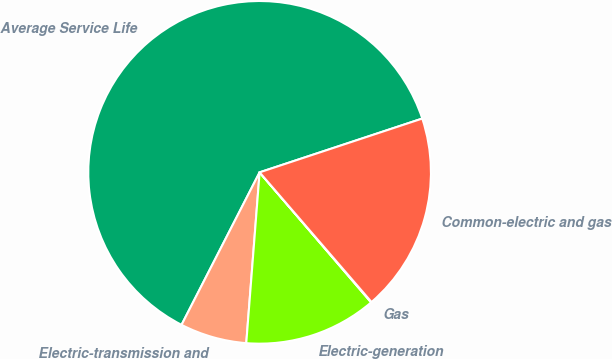Convert chart to OTSL. <chart><loc_0><loc_0><loc_500><loc_500><pie_chart><fcel>Average Service Life<fcel>Electric-transmission and<fcel>Electric-generation<fcel>Gas<fcel>Common-electric and gas<nl><fcel>62.38%<fcel>6.29%<fcel>12.52%<fcel>0.05%<fcel>18.75%<nl></chart> 